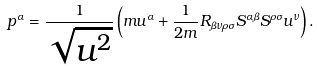Convert formula to latex. <formula><loc_0><loc_0><loc_500><loc_500>p ^ { \alpha } = \frac { 1 } { \sqrt { u ^ { 2 } } } \left ( m u ^ { \alpha } + \frac { 1 } { 2 m } R _ { \beta \nu \rho \sigma } S ^ { \alpha \beta } S ^ { \rho \sigma } u ^ { \nu } \right ) .</formula> 